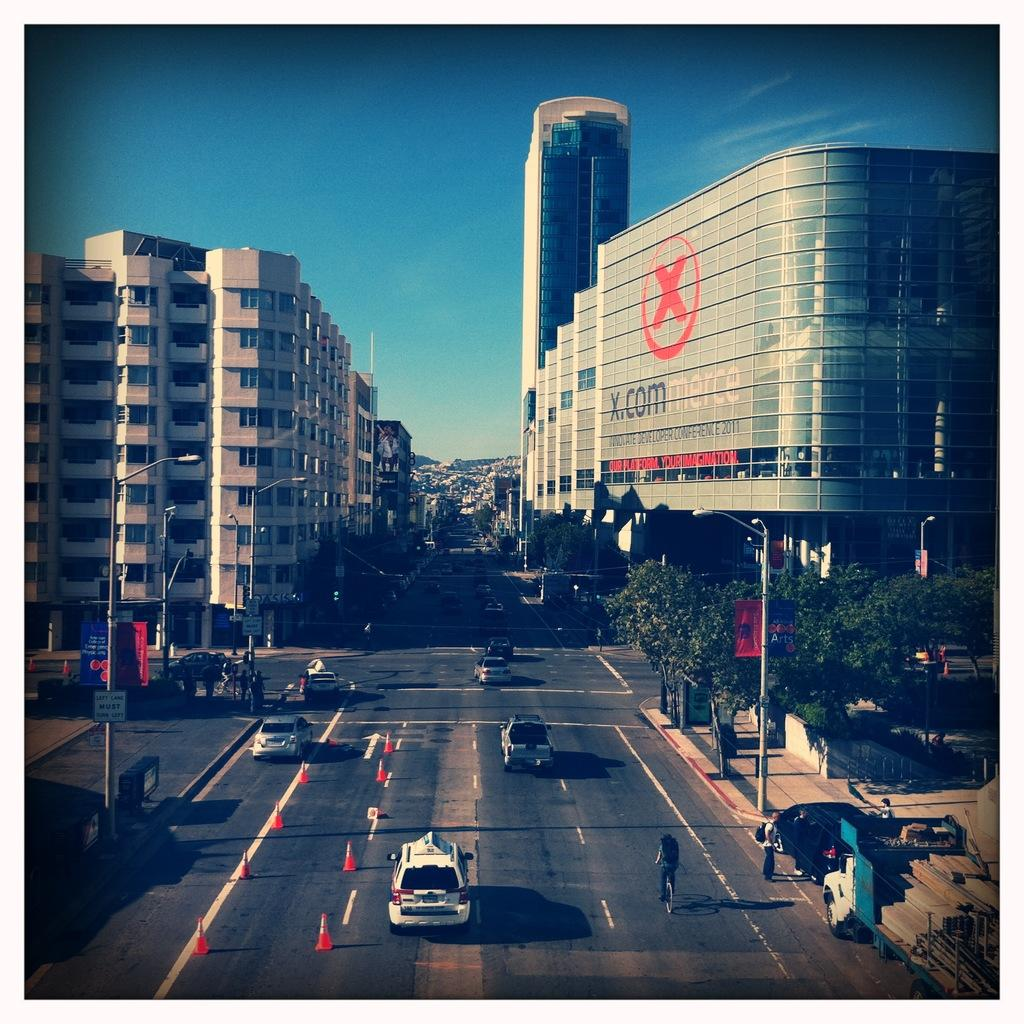What type of structures can be seen in the image? There are buildings in the image. What other natural or man-made elements can be seen in the image? There are trees, street lamps, traffic cones, and vehicles visible in the image. Are there any signs of human activity in the image? Yes, there are people walking in the image. What is visible at the top of the image? The sky is visible at the top of the image. What type of wall can be seen supporting the buildings in the image? There is no specific wall mentioned or visible in the image; it simply shows buildings, trees, street lamps, traffic cones, vehicles, and people walking. What type of beam is holding up the traffic cones in the image? There is no beam holding up the traffic cones in the image; they are simply placed on the ground. 